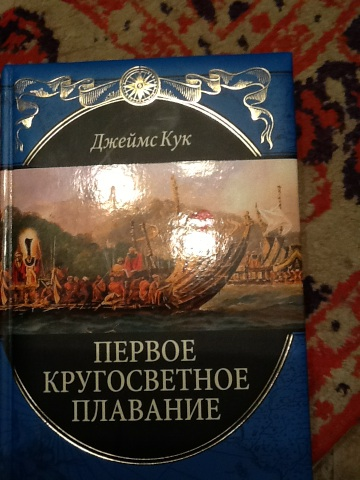What book is this? This is a Russian edition of the book titled 'Первое кругосветное плавание,' which translates to 'The First Circumnavigation.' The author's name is Джеймс Кук, which is James Cook in English. 